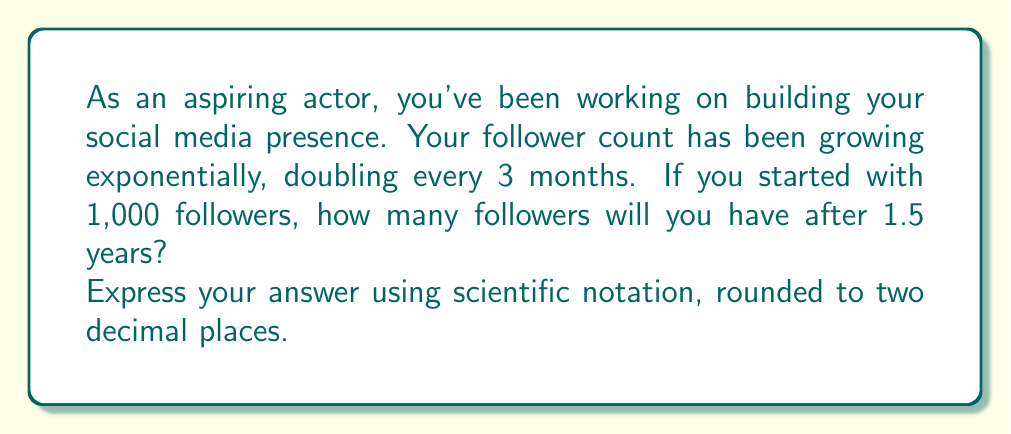Solve this math problem. Let's approach this step-by-step:

1) First, we need to identify the components of our exponential function:
   - Initial value (a): 1,000 followers
   - Growth rate (r): doubles every 3 months, so $2^{\frac{1}{3}}$ per month
   - Time (t): 1.5 years = 18 months

2) Our exponential function is of the form:
   $$ f(t) = a \cdot (r)^t $$

3) Substituting our values:
   $$ f(18) = 1000 \cdot (2^{\frac{1}{3}})^{18} $$

4) Simplify the exponent:
   $$ f(18) = 1000 \cdot 2^{\frac{18}{3}} = 1000 \cdot 2^6 $$

5) Calculate:
   $$ f(18) = 1000 \cdot 64 = 64,000 $$

6) Express in scientific notation, rounded to two decimal places:
   $$ 6.40 \times 10^4 $$

This exponential growth demonstrates how quickly a social media following can expand, which is crucial for an aspiring actor's career development.
Answer: $6.40 \times 10^4$ 